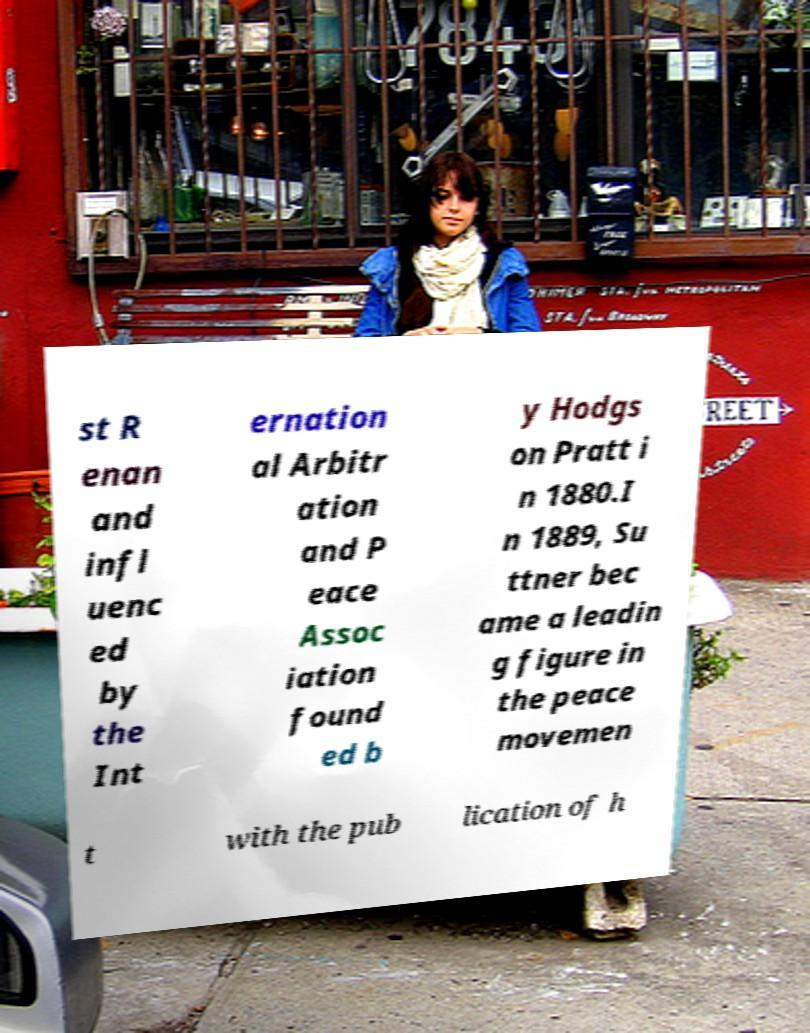For documentation purposes, I need the text within this image transcribed. Could you provide that? st R enan and infl uenc ed by the Int ernation al Arbitr ation and P eace Assoc iation found ed b y Hodgs on Pratt i n 1880.I n 1889, Su ttner bec ame a leadin g figure in the peace movemen t with the pub lication of h 